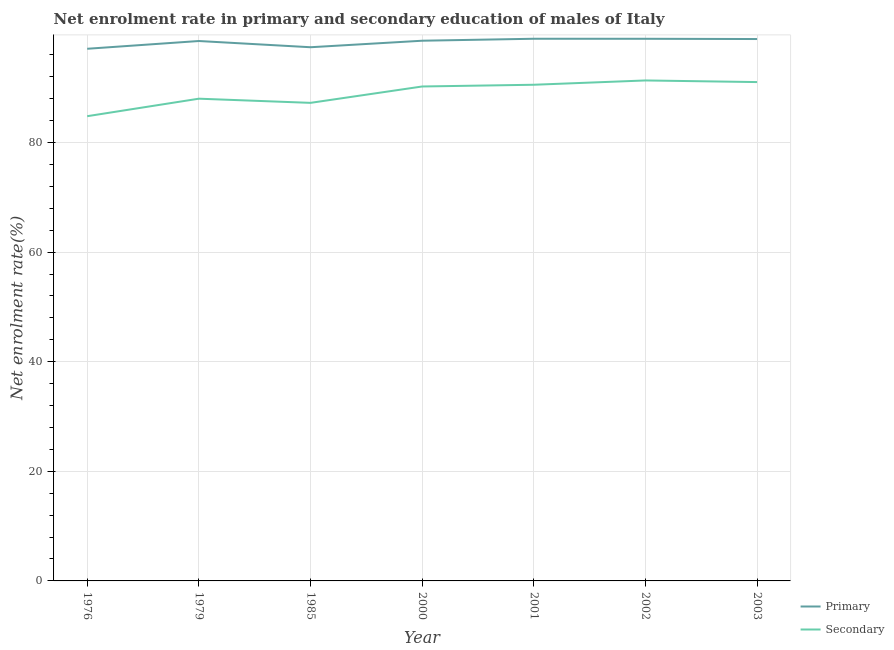Does the line corresponding to enrollment rate in primary education intersect with the line corresponding to enrollment rate in secondary education?
Make the answer very short. No. Is the number of lines equal to the number of legend labels?
Your answer should be very brief. Yes. What is the enrollment rate in primary education in 1976?
Your answer should be compact. 97.1. Across all years, what is the maximum enrollment rate in primary education?
Provide a succinct answer. 98.93. Across all years, what is the minimum enrollment rate in secondary education?
Your answer should be very brief. 84.8. In which year was the enrollment rate in primary education maximum?
Offer a terse response. 2001. In which year was the enrollment rate in primary education minimum?
Make the answer very short. 1976. What is the total enrollment rate in secondary education in the graph?
Provide a short and direct response. 623.13. What is the difference between the enrollment rate in primary education in 1976 and that in 2002?
Your answer should be compact. -1.82. What is the difference between the enrollment rate in primary education in 1979 and the enrollment rate in secondary education in 2003?
Give a very brief answer. 7.49. What is the average enrollment rate in secondary education per year?
Offer a very short reply. 89.02. In the year 2002, what is the difference between the enrollment rate in secondary education and enrollment rate in primary education?
Offer a very short reply. -7.6. What is the ratio of the enrollment rate in secondary education in 1976 to that in 1985?
Your answer should be very brief. 0.97. Is the difference between the enrollment rate in secondary education in 1976 and 2003 greater than the difference between the enrollment rate in primary education in 1976 and 2003?
Your response must be concise. No. What is the difference between the highest and the second highest enrollment rate in secondary education?
Your response must be concise. 0.3. What is the difference between the highest and the lowest enrollment rate in primary education?
Make the answer very short. 1.83. Is the sum of the enrollment rate in primary education in 1985 and 2000 greater than the maximum enrollment rate in secondary education across all years?
Provide a short and direct response. Yes. Is the enrollment rate in secondary education strictly greater than the enrollment rate in primary education over the years?
Keep it short and to the point. No. Is the enrollment rate in secondary education strictly less than the enrollment rate in primary education over the years?
Offer a very short reply. Yes. How many years are there in the graph?
Your response must be concise. 7. What is the difference between two consecutive major ticks on the Y-axis?
Give a very brief answer. 20. Are the values on the major ticks of Y-axis written in scientific E-notation?
Make the answer very short. No. Does the graph contain any zero values?
Your answer should be compact. No. Does the graph contain grids?
Ensure brevity in your answer.  Yes. How many legend labels are there?
Your answer should be compact. 2. How are the legend labels stacked?
Your answer should be compact. Vertical. What is the title of the graph?
Your answer should be very brief. Net enrolment rate in primary and secondary education of males of Italy. What is the label or title of the X-axis?
Give a very brief answer. Year. What is the label or title of the Y-axis?
Provide a succinct answer. Net enrolment rate(%). What is the Net enrolment rate(%) in Primary in 1976?
Your answer should be very brief. 97.1. What is the Net enrolment rate(%) of Secondary in 1976?
Your answer should be very brief. 84.8. What is the Net enrolment rate(%) in Primary in 1979?
Ensure brevity in your answer.  98.52. What is the Net enrolment rate(%) of Secondary in 1979?
Give a very brief answer. 87.99. What is the Net enrolment rate(%) of Primary in 1985?
Offer a very short reply. 97.38. What is the Net enrolment rate(%) in Secondary in 1985?
Offer a very short reply. 87.23. What is the Net enrolment rate(%) in Primary in 2000?
Offer a terse response. 98.57. What is the Net enrolment rate(%) in Secondary in 2000?
Provide a succinct answer. 90.22. What is the Net enrolment rate(%) in Primary in 2001?
Make the answer very short. 98.93. What is the Net enrolment rate(%) of Secondary in 2001?
Keep it short and to the point. 90.54. What is the Net enrolment rate(%) of Primary in 2002?
Your answer should be compact. 98.92. What is the Net enrolment rate(%) in Secondary in 2002?
Ensure brevity in your answer.  91.32. What is the Net enrolment rate(%) in Primary in 2003?
Offer a very short reply. 98.88. What is the Net enrolment rate(%) in Secondary in 2003?
Keep it short and to the point. 91.02. Across all years, what is the maximum Net enrolment rate(%) in Primary?
Keep it short and to the point. 98.93. Across all years, what is the maximum Net enrolment rate(%) of Secondary?
Your answer should be very brief. 91.32. Across all years, what is the minimum Net enrolment rate(%) in Primary?
Give a very brief answer. 97.1. Across all years, what is the minimum Net enrolment rate(%) in Secondary?
Keep it short and to the point. 84.8. What is the total Net enrolment rate(%) of Primary in the graph?
Give a very brief answer. 688.3. What is the total Net enrolment rate(%) of Secondary in the graph?
Offer a terse response. 623.13. What is the difference between the Net enrolment rate(%) in Primary in 1976 and that in 1979?
Give a very brief answer. -1.42. What is the difference between the Net enrolment rate(%) in Secondary in 1976 and that in 1979?
Ensure brevity in your answer.  -3.19. What is the difference between the Net enrolment rate(%) of Primary in 1976 and that in 1985?
Your answer should be compact. -0.28. What is the difference between the Net enrolment rate(%) of Secondary in 1976 and that in 1985?
Keep it short and to the point. -2.43. What is the difference between the Net enrolment rate(%) in Primary in 1976 and that in 2000?
Offer a terse response. -1.47. What is the difference between the Net enrolment rate(%) of Secondary in 1976 and that in 2000?
Keep it short and to the point. -5.42. What is the difference between the Net enrolment rate(%) of Primary in 1976 and that in 2001?
Ensure brevity in your answer.  -1.83. What is the difference between the Net enrolment rate(%) in Secondary in 1976 and that in 2001?
Make the answer very short. -5.74. What is the difference between the Net enrolment rate(%) of Primary in 1976 and that in 2002?
Provide a short and direct response. -1.82. What is the difference between the Net enrolment rate(%) of Secondary in 1976 and that in 2002?
Offer a very short reply. -6.52. What is the difference between the Net enrolment rate(%) of Primary in 1976 and that in 2003?
Provide a short and direct response. -1.78. What is the difference between the Net enrolment rate(%) in Secondary in 1976 and that in 2003?
Offer a very short reply. -6.23. What is the difference between the Net enrolment rate(%) in Primary in 1979 and that in 1985?
Ensure brevity in your answer.  1.14. What is the difference between the Net enrolment rate(%) of Secondary in 1979 and that in 1985?
Ensure brevity in your answer.  0.76. What is the difference between the Net enrolment rate(%) of Primary in 1979 and that in 2000?
Make the answer very short. -0.05. What is the difference between the Net enrolment rate(%) of Secondary in 1979 and that in 2000?
Give a very brief answer. -2.23. What is the difference between the Net enrolment rate(%) of Primary in 1979 and that in 2001?
Provide a short and direct response. -0.41. What is the difference between the Net enrolment rate(%) in Secondary in 1979 and that in 2001?
Offer a very short reply. -2.54. What is the difference between the Net enrolment rate(%) in Primary in 1979 and that in 2002?
Your response must be concise. -0.41. What is the difference between the Net enrolment rate(%) in Secondary in 1979 and that in 2002?
Ensure brevity in your answer.  -3.33. What is the difference between the Net enrolment rate(%) in Primary in 1979 and that in 2003?
Keep it short and to the point. -0.36. What is the difference between the Net enrolment rate(%) of Secondary in 1979 and that in 2003?
Ensure brevity in your answer.  -3.03. What is the difference between the Net enrolment rate(%) of Primary in 1985 and that in 2000?
Your response must be concise. -1.19. What is the difference between the Net enrolment rate(%) of Secondary in 1985 and that in 2000?
Offer a very short reply. -2.99. What is the difference between the Net enrolment rate(%) in Primary in 1985 and that in 2001?
Offer a very short reply. -1.55. What is the difference between the Net enrolment rate(%) of Secondary in 1985 and that in 2001?
Keep it short and to the point. -3.3. What is the difference between the Net enrolment rate(%) in Primary in 1985 and that in 2002?
Keep it short and to the point. -1.54. What is the difference between the Net enrolment rate(%) in Secondary in 1985 and that in 2002?
Offer a terse response. -4.09. What is the difference between the Net enrolment rate(%) of Primary in 1985 and that in 2003?
Ensure brevity in your answer.  -1.5. What is the difference between the Net enrolment rate(%) in Secondary in 1985 and that in 2003?
Your answer should be very brief. -3.79. What is the difference between the Net enrolment rate(%) in Primary in 2000 and that in 2001?
Your response must be concise. -0.36. What is the difference between the Net enrolment rate(%) in Secondary in 2000 and that in 2001?
Your answer should be compact. -0.32. What is the difference between the Net enrolment rate(%) of Primary in 2000 and that in 2002?
Offer a very short reply. -0.35. What is the difference between the Net enrolment rate(%) in Secondary in 2000 and that in 2002?
Keep it short and to the point. -1.1. What is the difference between the Net enrolment rate(%) in Primary in 2000 and that in 2003?
Provide a short and direct response. -0.31. What is the difference between the Net enrolment rate(%) in Secondary in 2000 and that in 2003?
Your response must be concise. -0.81. What is the difference between the Net enrolment rate(%) of Primary in 2001 and that in 2002?
Your answer should be very brief. 0.01. What is the difference between the Net enrolment rate(%) of Secondary in 2001 and that in 2002?
Provide a short and direct response. -0.79. What is the difference between the Net enrolment rate(%) in Primary in 2001 and that in 2003?
Your answer should be very brief. 0.05. What is the difference between the Net enrolment rate(%) in Secondary in 2001 and that in 2003?
Give a very brief answer. -0.49. What is the difference between the Net enrolment rate(%) in Primary in 2002 and that in 2003?
Make the answer very short. 0.04. What is the difference between the Net enrolment rate(%) of Secondary in 2002 and that in 2003?
Offer a terse response. 0.3. What is the difference between the Net enrolment rate(%) in Primary in 1976 and the Net enrolment rate(%) in Secondary in 1979?
Provide a short and direct response. 9.11. What is the difference between the Net enrolment rate(%) of Primary in 1976 and the Net enrolment rate(%) of Secondary in 1985?
Offer a terse response. 9.87. What is the difference between the Net enrolment rate(%) in Primary in 1976 and the Net enrolment rate(%) in Secondary in 2000?
Offer a very short reply. 6.88. What is the difference between the Net enrolment rate(%) in Primary in 1976 and the Net enrolment rate(%) in Secondary in 2001?
Your response must be concise. 6.56. What is the difference between the Net enrolment rate(%) of Primary in 1976 and the Net enrolment rate(%) of Secondary in 2002?
Your answer should be very brief. 5.78. What is the difference between the Net enrolment rate(%) in Primary in 1976 and the Net enrolment rate(%) in Secondary in 2003?
Provide a succinct answer. 6.08. What is the difference between the Net enrolment rate(%) in Primary in 1979 and the Net enrolment rate(%) in Secondary in 1985?
Offer a very short reply. 11.28. What is the difference between the Net enrolment rate(%) in Primary in 1979 and the Net enrolment rate(%) in Secondary in 2000?
Offer a very short reply. 8.3. What is the difference between the Net enrolment rate(%) in Primary in 1979 and the Net enrolment rate(%) in Secondary in 2001?
Give a very brief answer. 7.98. What is the difference between the Net enrolment rate(%) in Primary in 1979 and the Net enrolment rate(%) in Secondary in 2002?
Offer a very short reply. 7.2. What is the difference between the Net enrolment rate(%) in Primary in 1979 and the Net enrolment rate(%) in Secondary in 2003?
Provide a short and direct response. 7.49. What is the difference between the Net enrolment rate(%) of Primary in 1985 and the Net enrolment rate(%) of Secondary in 2000?
Your response must be concise. 7.16. What is the difference between the Net enrolment rate(%) of Primary in 1985 and the Net enrolment rate(%) of Secondary in 2001?
Offer a very short reply. 6.84. What is the difference between the Net enrolment rate(%) in Primary in 1985 and the Net enrolment rate(%) in Secondary in 2002?
Keep it short and to the point. 6.06. What is the difference between the Net enrolment rate(%) in Primary in 1985 and the Net enrolment rate(%) in Secondary in 2003?
Give a very brief answer. 6.36. What is the difference between the Net enrolment rate(%) in Primary in 2000 and the Net enrolment rate(%) in Secondary in 2001?
Give a very brief answer. 8.03. What is the difference between the Net enrolment rate(%) of Primary in 2000 and the Net enrolment rate(%) of Secondary in 2002?
Your answer should be very brief. 7.25. What is the difference between the Net enrolment rate(%) of Primary in 2000 and the Net enrolment rate(%) of Secondary in 2003?
Offer a terse response. 7.54. What is the difference between the Net enrolment rate(%) in Primary in 2001 and the Net enrolment rate(%) in Secondary in 2002?
Make the answer very short. 7.61. What is the difference between the Net enrolment rate(%) in Primary in 2001 and the Net enrolment rate(%) in Secondary in 2003?
Ensure brevity in your answer.  7.91. What is the difference between the Net enrolment rate(%) in Primary in 2002 and the Net enrolment rate(%) in Secondary in 2003?
Provide a short and direct response. 7.9. What is the average Net enrolment rate(%) of Primary per year?
Your response must be concise. 98.33. What is the average Net enrolment rate(%) in Secondary per year?
Make the answer very short. 89.02. In the year 1976, what is the difference between the Net enrolment rate(%) of Primary and Net enrolment rate(%) of Secondary?
Your response must be concise. 12.3. In the year 1979, what is the difference between the Net enrolment rate(%) in Primary and Net enrolment rate(%) in Secondary?
Give a very brief answer. 10.52. In the year 1985, what is the difference between the Net enrolment rate(%) in Primary and Net enrolment rate(%) in Secondary?
Offer a terse response. 10.15. In the year 2000, what is the difference between the Net enrolment rate(%) in Primary and Net enrolment rate(%) in Secondary?
Give a very brief answer. 8.35. In the year 2001, what is the difference between the Net enrolment rate(%) of Primary and Net enrolment rate(%) of Secondary?
Provide a short and direct response. 8.39. In the year 2002, what is the difference between the Net enrolment rate(%) of Primary and Net enrolment rate(%) of Secondary?
Make the answer very short. 7.6. In the year 2003, what is the difference between the Net enrolment rate(%) of Primary and Net enrolment rate(%) of Secondary?
Make the answer very short. 7.85. What is the ratio of the Net enrolment rate(%) of Primary in 1976 to that in 1979?
Give a very brief answer. 0.99. What is the ratio of the Net enrolment rate(%) in Secondary in 1976 to that in 1979?
Ensure brevity in your answer.  0.96. What is the ratio of the Net enrolment rate(%) of Primary in 1976 to that in 1985?
Provide a short and direct response. 1. What is the ratio of the Net enrolment rate(%) in Secondary in 1976 to that in 1985?
Ensure brevity in your answer.  0.97. What is the ratio of the Net enrolment rate(%) of Primary in 1976 to that in 2000?
Your response must be concise. 0.99. What is the ratio of the Net enrolment rate(%) of Secondary in 1976 to that in 2000?
Offer a terse response. 0.94. What is the ratio of the Net enrolment rate(%) of Primary in 1976 to that in 2001?
Give a very brief answer. 0.98. What is the ratio of the Net enrolment rate(%) of Secondary in 1976 to that in 2001?
Give a very brief answer. 0.94. What is the ratio of the Net enrolment rate(%) in Primary in 1976 to that in 2002?
Your answer should be very brief. 0.98. What is the ratio of the Net enrolment rate(%) of Secondary in 1976 to that in 2003?
Keep it short and to the point. 0.93. What is the ratio of the Net enrolment rate(%) of Primary in 1979 to that in 1985?
Ensure brevity in your answer.  1.01. What is the ratio of the Net enrolment rate(%) in Secondary in 1979 to that in 1985?
Provide a succinct answer. 1.01. What is the ratio of the Net enrolment rate(%) in Secondary in 1979 to that in 2000?
Offer a very short reply. 0.98. What is the ratio of the Net enrolment rate(%) in Primary in 1979 to that in 2001?
Ensure brevity in your answer.  1. What is the ratio of the Net enrolment rate(%) in Secondary in 1979 to that in 2001?
Provide a succinct answer. 0.97. What is the ratio of the Net enrolment rate(%) in Secondary in 1979 to that in 2002?
Offer a terse response. 0.96. What is the ratio of the Net enrolment rate(%) of Secondary in 1979 to that in 2003?
Your response must be concise. 0.97. What is the ratio of the Net enrolment rate(%) in Primary in 1985 to that in 2000?
Give a very brief answer. 0.99. What is the ratio of the Net enrolment rate(%) of Secondary in 1985 to that in 2000?
Provide a succinct answer. 0.97. What is the ratio of the Net enrolment rate(%) of Primary in 1985 to that in 2001?
Make the answer very short. 0.98. What is the ratio of the Net enrolment rate(%) of Secondary in 1985 to that in 2001?
Make the answer very short. 0.96. What is the ratio of the Net enrolment rate(%) of Primary in 1985 to that in 2002?
Your response must be concise. 0.98. What is the ratio of the Net enrolment rate(%) of Secondary in 1985 to that in 2002?
Your answer should be very brief. 0.96. What is the ratio of the Net enrolment rate(%) in Primary in 1985 to that in 2003?
Your answer should be compact. 0.98. What is the ratio of the Net enrolment rate(%) in Primary in 2000 to that in 2001?
Provide a succinct answer. 1. What is the ratio of the Net enrolment rate(%) of Secondary in 2000 to that in 2002?
Keep it short and to the point. 0.99. What is the ratio of the Net enrolment rate(%) of Primary in 2000 to that in 2003?
Your answer should be very brief. 1. What is the ratio of the Net enrolment rate(%) of Secondary in 2000 to that in 2003?
Your answer should be very brief. 0.99. What is the ratio of the Net enrolment rate(%) in Secondary in 2001 to that in 2003?
Your answer should be very brief. 0.99. What is the ratio of the Net enrolment rate(%) in Secondary in 2002 to that in 2003?
Provide a short and direct response. 1. What is the difference between the highest and the second highest Net enrolment rate(%) in Primary?
Ensure brevity in your answer.  0.01. What is the difference between the highest and the second highest Net enrolment rate(%) of Secondary?
Make the answer very short. 0.3. What is the difference between the highest and the lowest Net enrolment rate(%) in Primary?
Ensure brevity in your answer.  1.83. What is the difference between the highest and the lowest Net enrolment rate(%) of Secondary?
Offer a terse response. 6.52. 